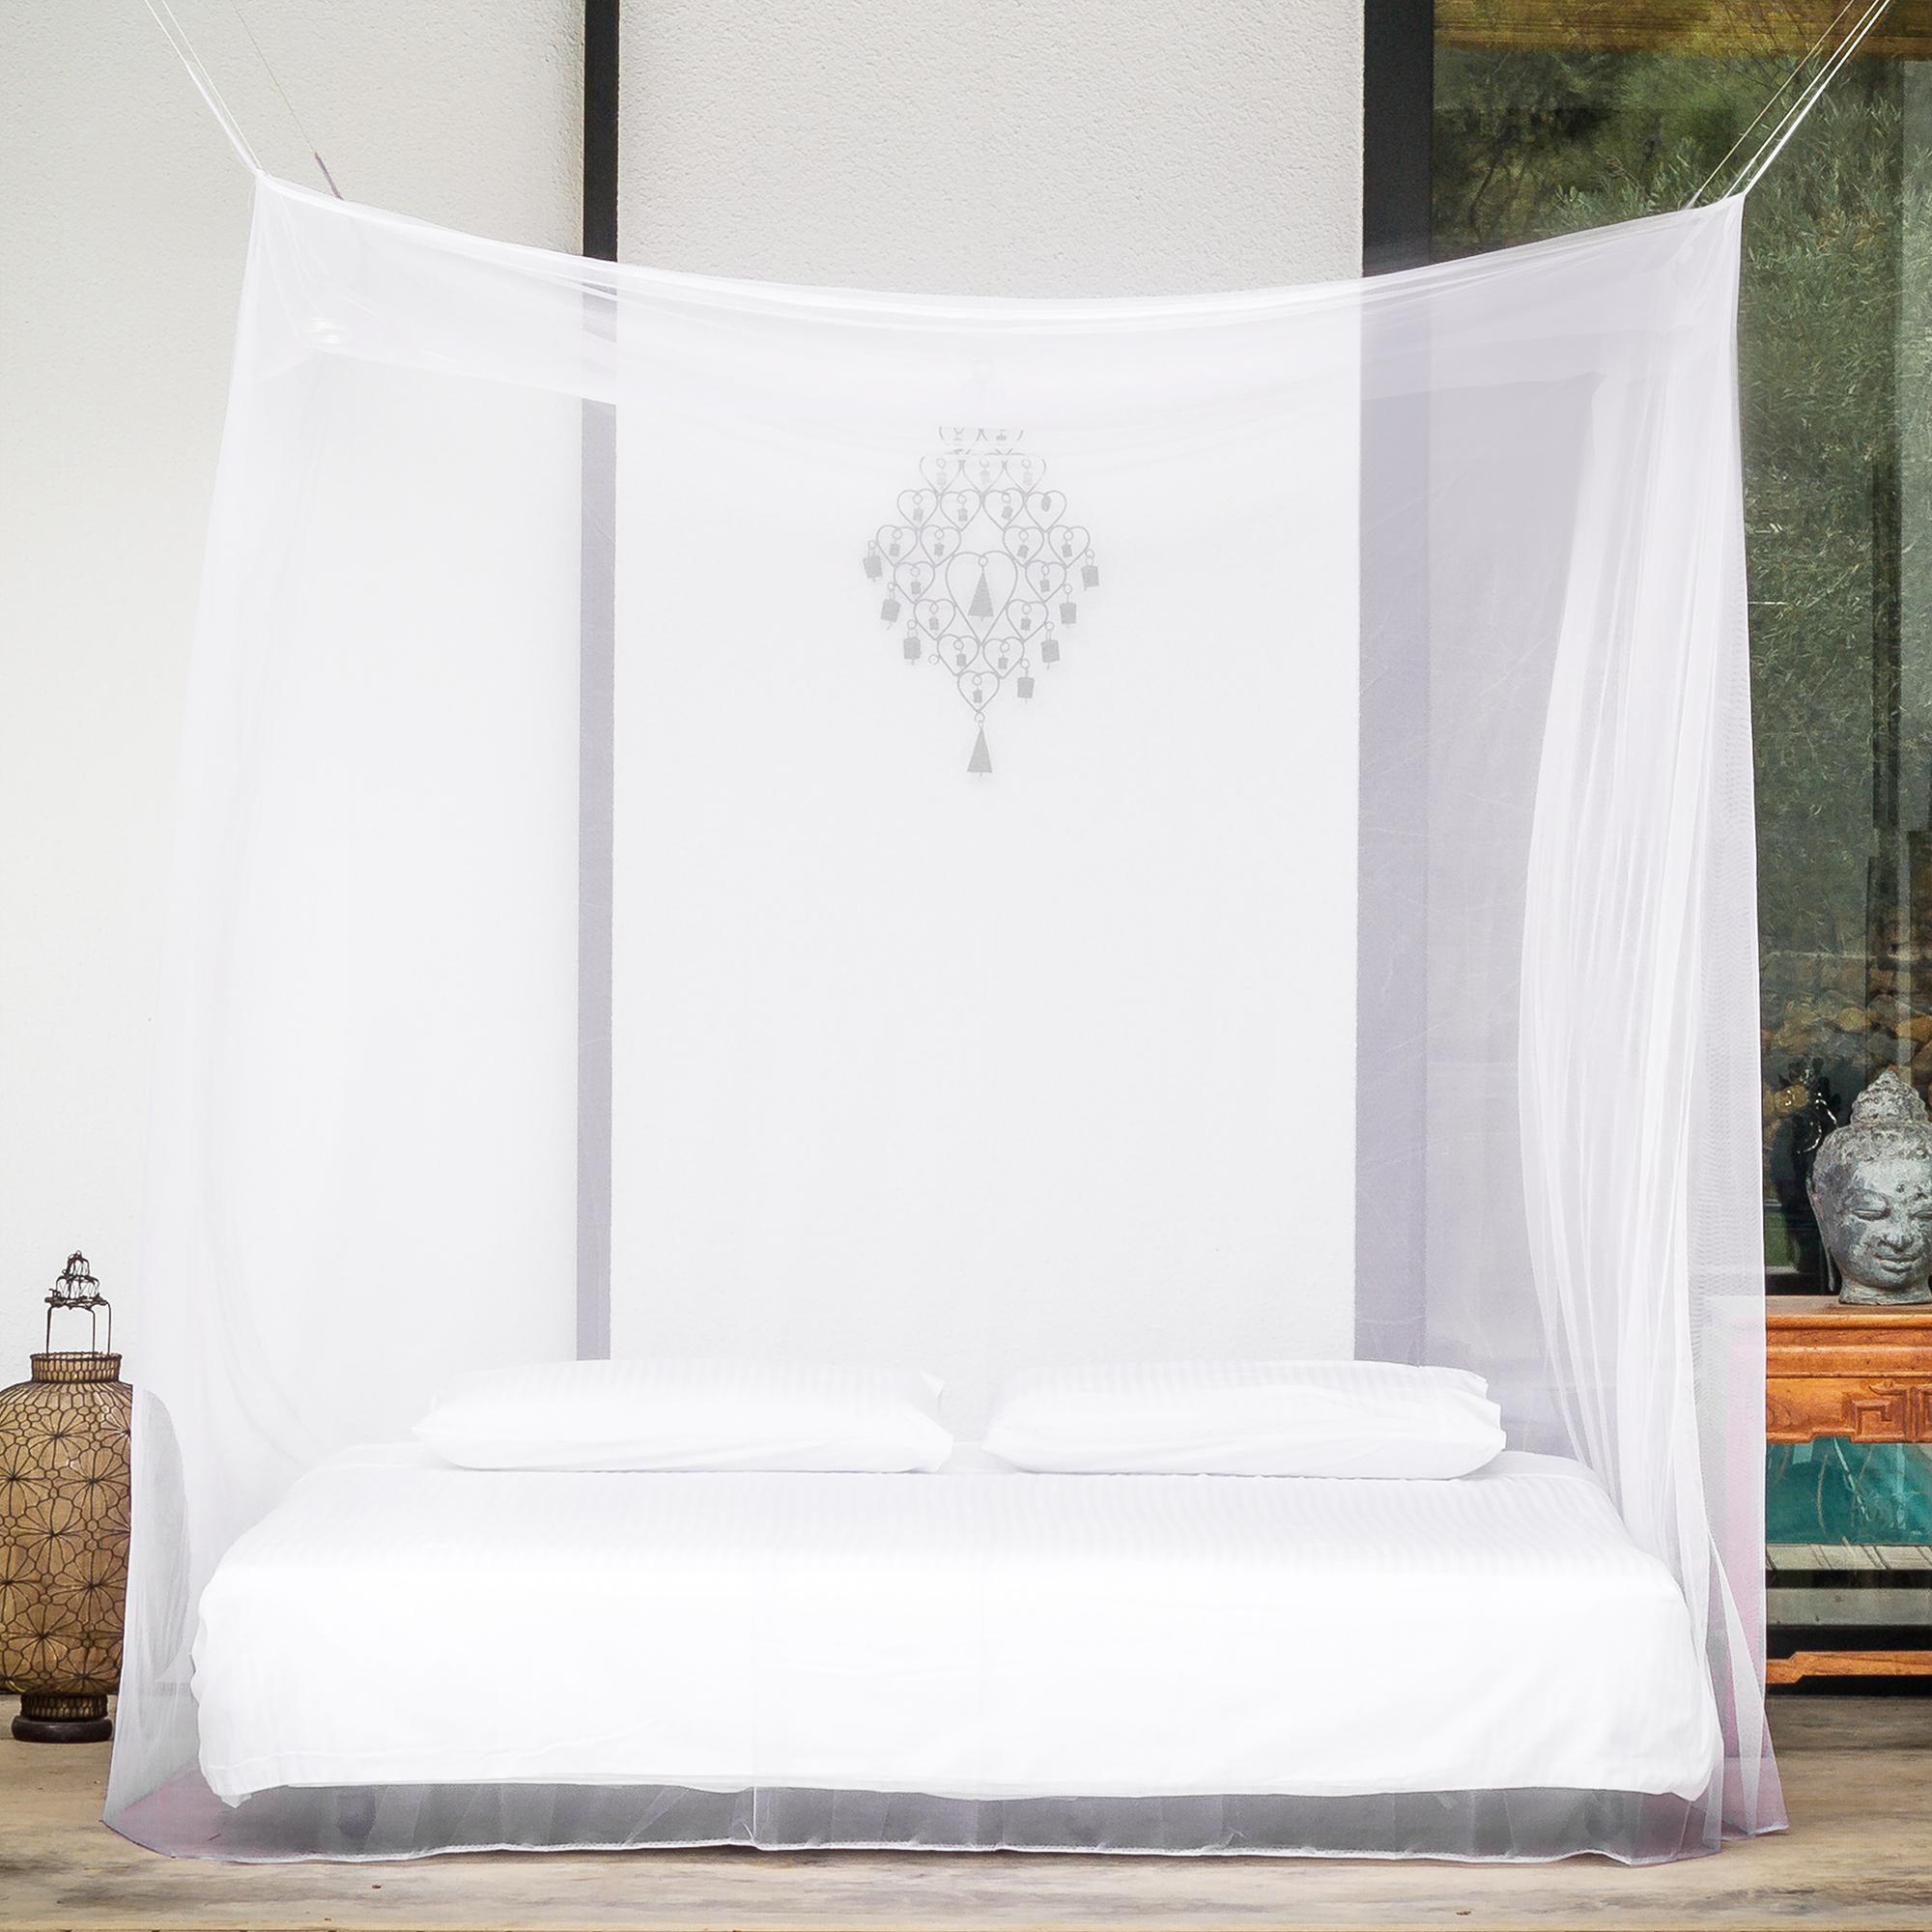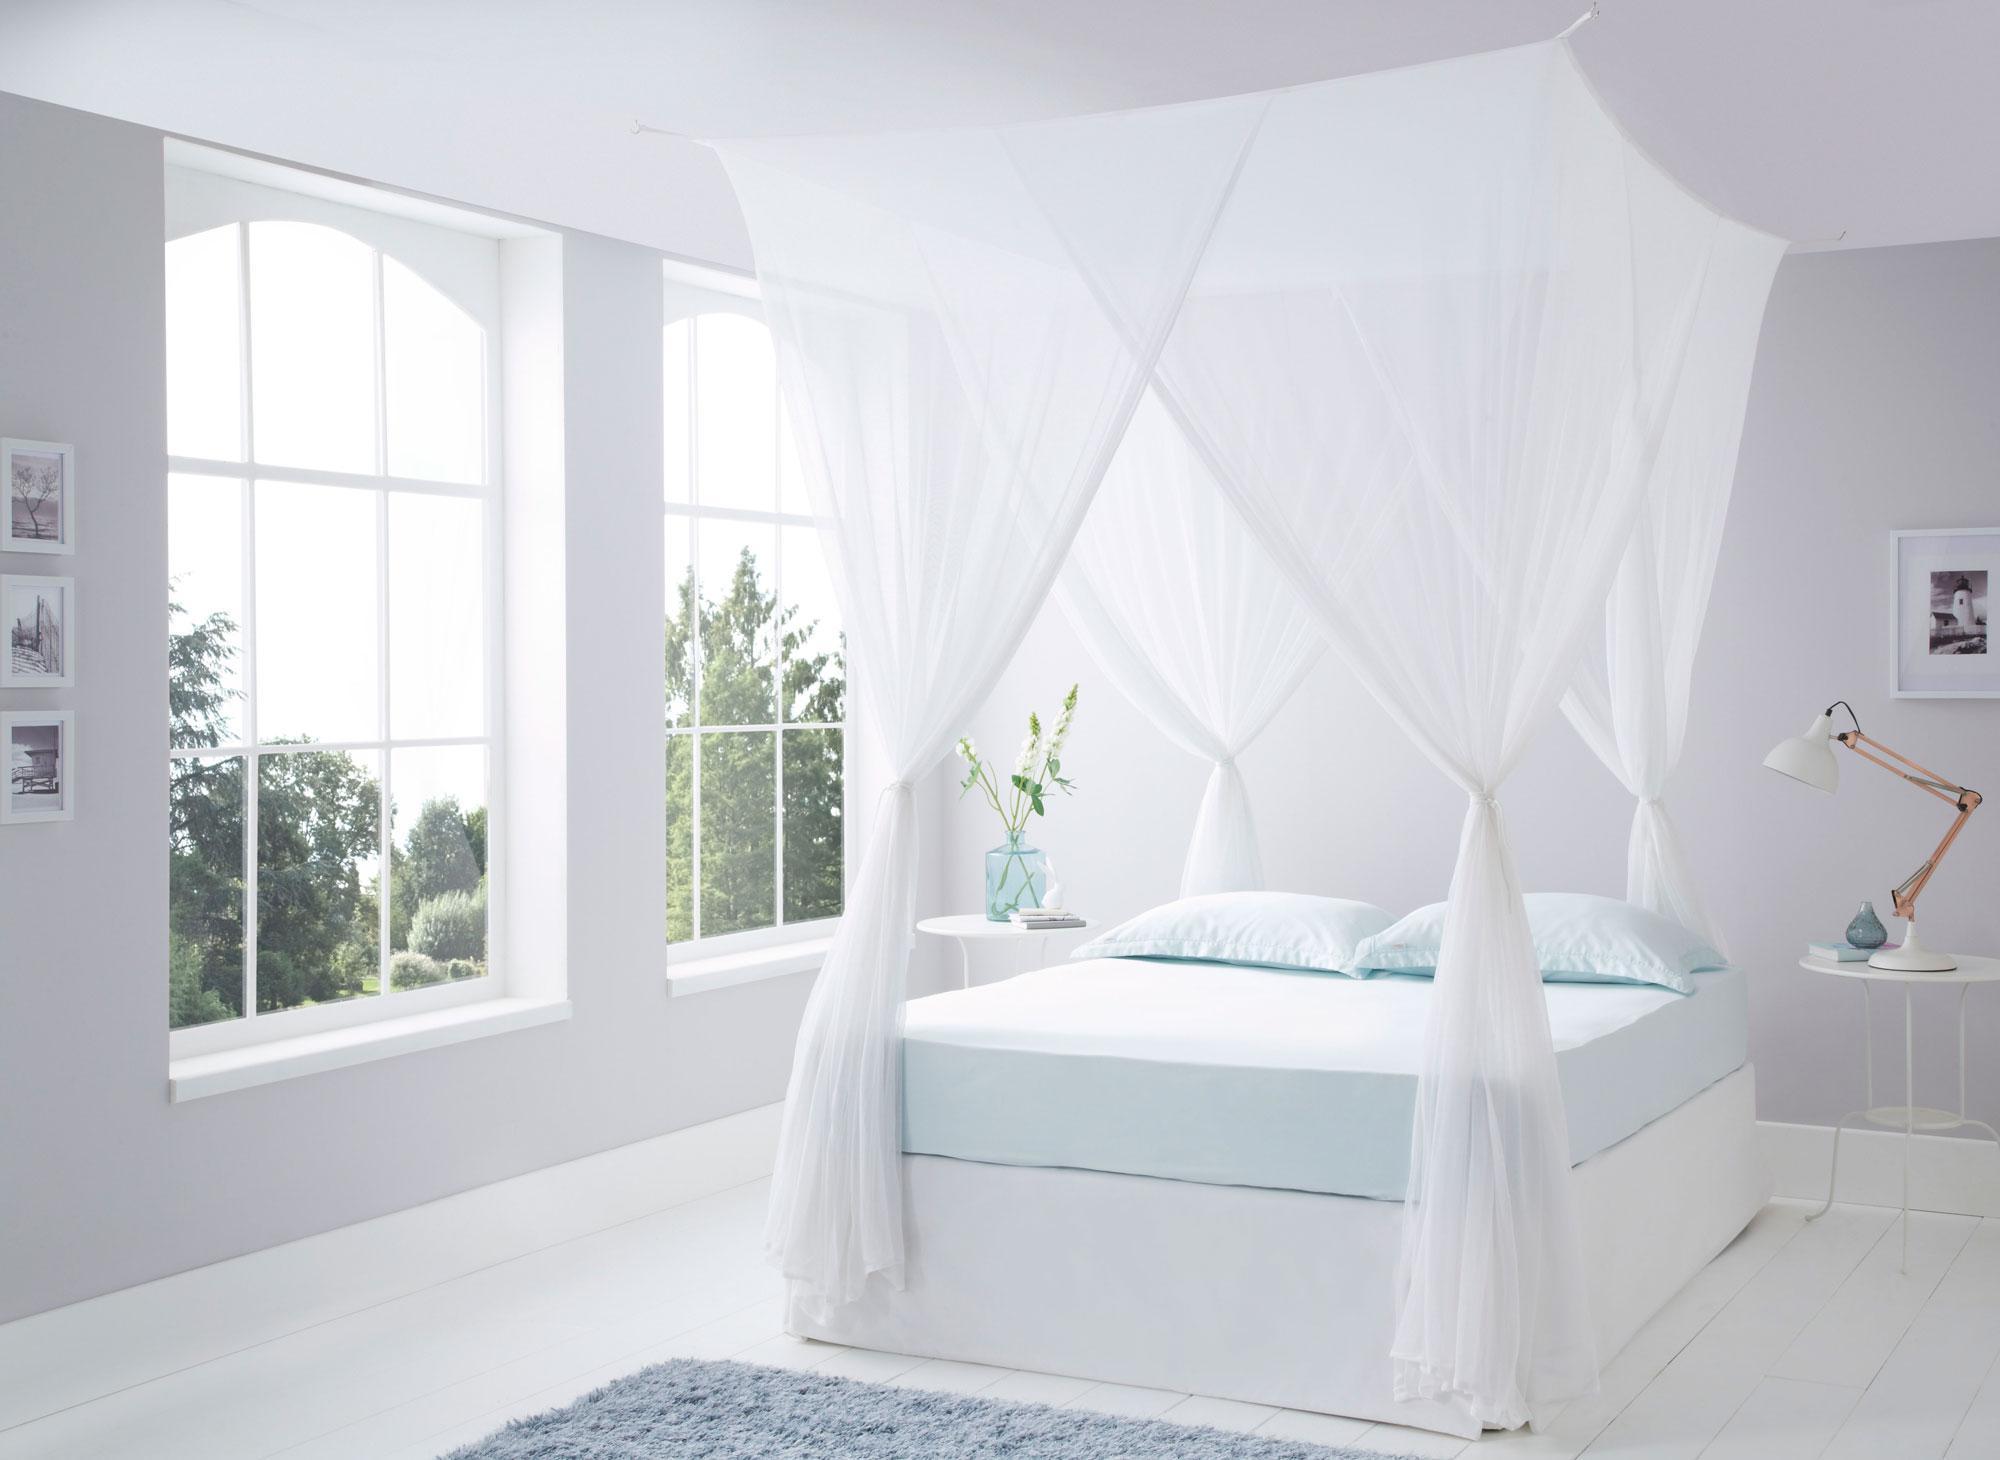The first image is the image on the left, the second image is the image on the right. For the images shown, is this caption "One image shows a head-on view of a bed surrounded by a square sheer white canopy that covers the foot of the bed and suspends from its top corners." true? Answer yes or no. Yes. The first image is the image on the left, the second image is the image on the right. Analyze the images presented: Is the assertion "One bed net has a fabric bottom trim." valid? Answer yes or no. No. 